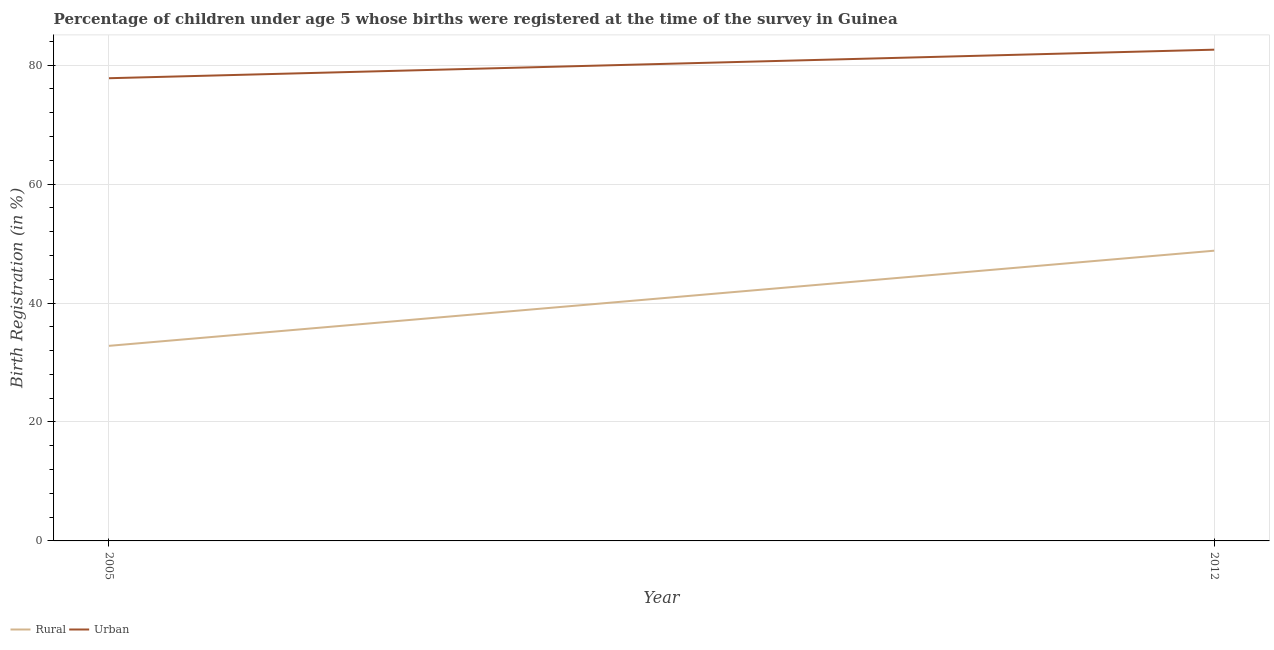How many different coloured lines are there?
Your response must be concise. 2. Does the line corresponding to rural birth registration intersect with the line corresponding to urban birth registration?
Give a very brief answer. No. What is the urban birth registration in 2012?
Offer a terse response. 82.6. Across all years, what is the maximum urban birth registration?
Offer a terse response. 82.6. Across all years, what is the minimum rural birth registration?
Your response must be concise. 32.8. In which year was the urban birth registration maximum?
Ensure brevity in your answer.  2012. In which year was the urban birth registration minimum?
Provide a succinct answer. 2005. What is the total rural birth registration in the graph?
Offer a terse response. 81.6. What is the difference between the rural birth registration in 2012 and the urban birth registration in 2005?
Your response must be concise. -29. What is the average rural birth registration per year?
Your answer should be compact. 40.8. In the year 2012, what is the difference between the rural birth registration and urban birth registration?
Offer a terse response. -33.8. What is the ratio of the urban birth registration in 2005 to that in 2012?
Keep it short and to the point. 0.94. Is the rural birth registration in 2005 less than that in 2012?
Give a very brief answer. Yes. Is the rural birth registration strictly less than the urban birth registration over the years?
Keep it short and to the point. Yes. How many years are there in the graph?
Your answer should be compact. 2. What is the difference between two consecutive major ticks on the Y-axis?
Make the answer very short. 20. Are the values on the major ticks of Y-axis written in scientific E-notation?
Ensure brevity in your answer.  No. Does the graph contain any zero values?
Your answer should be very brief. No. Does the graph contain grids?
Your answer should be compact. Yes. How are the legend labels stacked?
Offer a terse response. Horizontal. What is the title of the graph?
Ensure brevity in your answer.  Percentage of children under age 5 whose births were registered at the time of the survey in Guinea. Does "RDB concessional" appear as one of the legend labels in the graph?
Offer a terse response. No. What is the label or title of the X-axis?
Offer a very short reply. Year. What is the label or title of the Y-axis?
Ensure brevity in your answer.  Birth Registration (in %). What is the Birth Registration (in %) in Rural in 2005?
Provide a succinct answer. 32.8. What is the Birth Registration (in %) of Urban in 2005?
Keep it short and to the point. 77.8. What is the Birth Registration (in %) of Rural in 2012?
Offer a very short reply. 48.8. What is the Birth Registration (in %) of Urban in 2012?
Provide a succinct answer. 82.6. Across all years, what is the maximum Birth Registration (in %) in Rural?
Offer a very short reply. 48.8. Across all years, what is the maximum Birth Registration (in %) of Urban?
Offer a very short reply. 82.6. Across all years, what is the minimum Birth Registration (in %) of Rural?
Provide a short and direct response. 32.8. Across all years, what is the minimum Birth Registration (in %) in Urban?
Provide a succinct answer. 77.8. What is the total Birth Registration (in %) of Rural in the graph?
Your answer should be compact. 81.6. What is the total Birth Registration (in %) in Urban in the graph?
Your response must be concise. 160.4. What is the difference between the Birth Registration (in %) of Rural in 2005 and the Birth Registration (in %) of Urban in 2012?
Your answer should be very brief. -49.8. What is the average Birth Registration (in %) of Rural per year?
Ensure brevity in your answer.  40.8. What is the average Birth Registration (in %) in Urban per year?
Give a very brief answer. 80.2. In the year 2005, what is the difference between the Birth Registration (in %) in Rural and Birth Registration (in %) in Urban?
Keep it short and to the point. -45. In the year 2012, what is the difference between the Birth Registration (in %) in Rural and Birth Registration (in %) in Urban?
Your answer should be very brief. -33.8. What is the ratio of the Birth Registration (in %) of Rural in 2005 to that in 2012?
Give a very brief answer. 0.67. What is the ratio of the Birth Registration (in %) in Urban in 2005 to that in 2012?
Offer a very short reply. 0.94. What is the difference between the highest and the second highest Birth Registration (in %) of Rural?
Your answer should be compact. 16. What is the difference between the highest and the second highest Birth Registration (in %) of Urban?
Keep it short and to the point. 4.8. What is the difference between the highest and the lowest Birth Registration (in %) of Urban?
Make the answer very short. 4.8. 